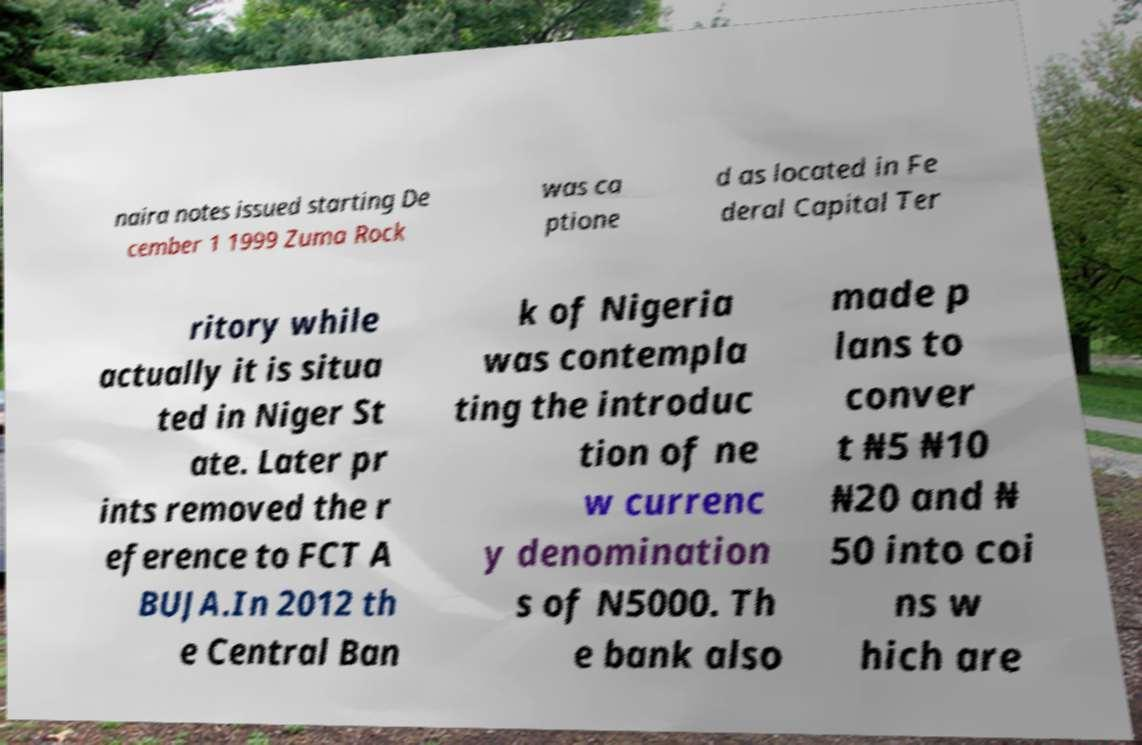Can you accurately transcribe the text from the provided image for me? naira notes issued starting De cember 1 1999 Zuma Rock was ca ptione d as located in Fe deral Capital Ter ritory while actually it is situa ted in Niger St ate. Later pr ints removed the r eference to FCT A BUJA.In 2012 th e Central Ban k of Nigeria was contempla ting the introduc tion of ne w currenc y denomination s of N5000. Th e bank also made p lans to conver t ₦5 ₦10 ₦20 and ₦ 50 into coi ns w hich are 